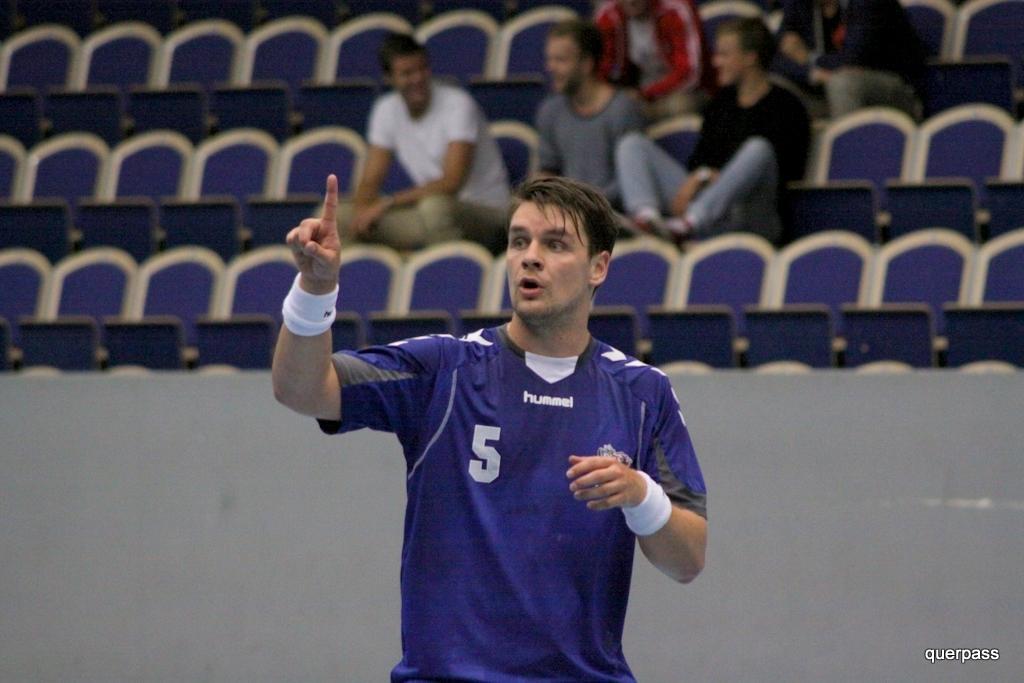Describe this image in one or two sentences. As we can see in the image there are few people here and there and chairs. The person standing in the front is wearing blue color t shirt. 